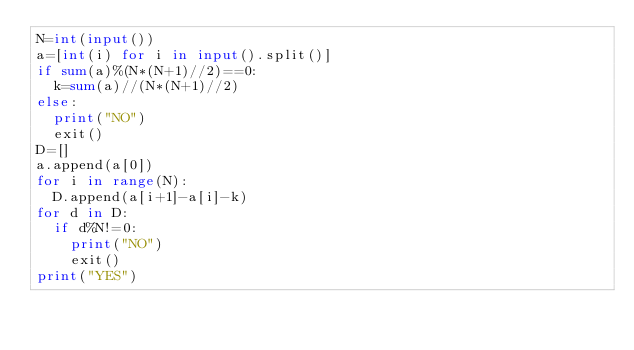<code> <loc_0><loc_0><loc_500><loc_500><_Python_>N=int(input())
a=[int(i) for i in input().split()]
if sum(a)%(N*(N+1)//2)==0:
  k=sum(a)//(N*(N+1)//2)
else:
  print("NO")
  exit()
D=[]
a.append(a[0])
for i in range(N):
  D.append(a[i+1]-a[i]-k)
for d in D:
  if d%N!=0:
    print("NO")
    exit()
print("YES")
    
  
</code> 